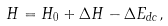Convert formula to latex. <formula><loc_0><loc_0><loc_500><loc_500>H = H _ { 0 } + \Delta H - \Delta E _ { d c } ,</formula> 